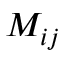Convert formula to latex. <formula><loc_0><loc_0><loc_500><loc_500>M _ { i j }</formula> 